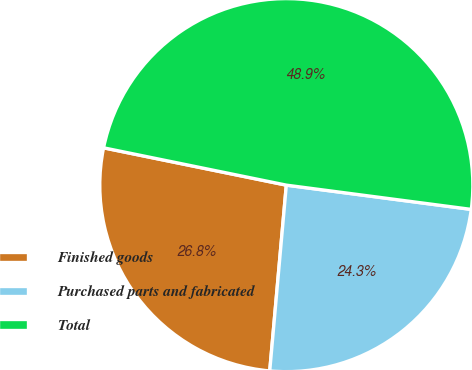Convert chart to OTSL. <chart><loc_0><loc_0><loc_500><loc_500><pie_chart><fcel>Finished goods<fcel>Purchased parts and fabricated<fcel>Total<nl><fcel>26.79%<fcel>24.34%<fcel>48.87%<nl></chart> 